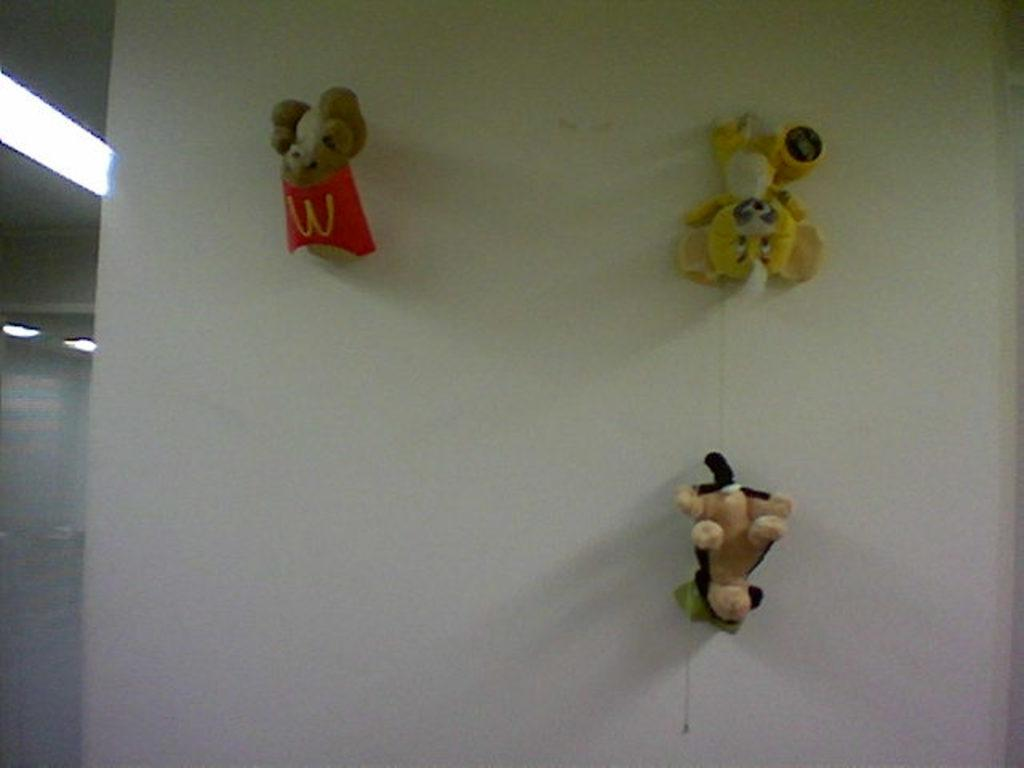How many teddy bears are in the image? There are three teddy bears in the image. Where are the teddy bears located? The teddy bears are attached to a wall. What color is the wall that the teddy bears are attached to? The wall is white. What can be seen on the left side of the image? There is a light on the left side of the image. What type of books are the teddy bears reading in the image? There are no books present in the image, and the teddy bears are not shown reading anything. 